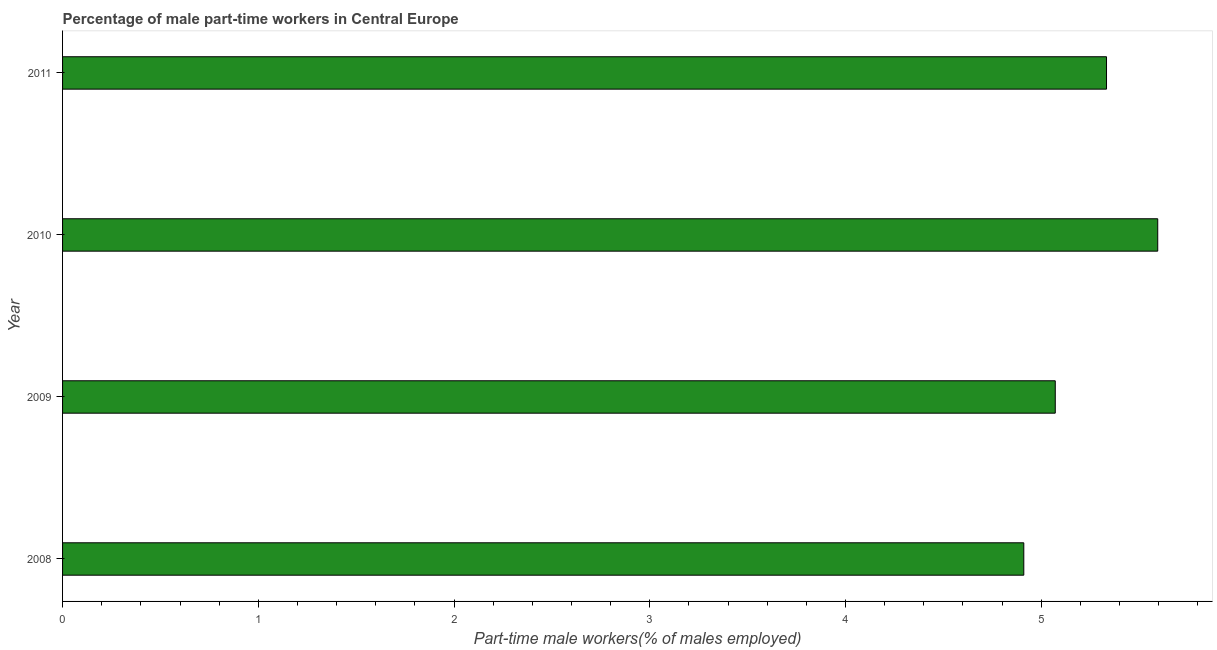Does the graph contain any zero values?
Your answer should be very brief. No. What is the title of the graph?
Offer a very short reply. Percentage of male part-time workers in Central Europe. What is the label or title of the X-axis?
Provide a succinct answer. Part-time male workers(% of males employed). What is the percentage of part-time male workers in 2010?
Provide a succinct answer. 5.6. Across all years, what is the maximum percentage of part-time male workers?
Ensure brevity in your answer.  5.6. Across all years, what is the minimum percentage of part-time male workers?
Provide a short and direct response. 4.91. In which year was the percentage of part-time male workers minimum?
Make the answer very short. 2008. What is the sum of the percentage of part-time male workers?
Your answer should be compact. 20.91. What is the difference between the percentage of part-time male workers in 2009 and 2011?
Provide a short and direct response. -0.26. What is the average percentage of part-time male workers per year?
Offer a very short reply. 5.23. What is the median percentage of part-time male workers?
Make the answer very short. 5.2. In how many years, is the percentage of part-time male workers greater than 3.2 %?
Give a very brief answer. 4. Do a majority of the years between 2011 and 2010 (inclusive) have percentage of part-time male workers greater than 0.2 %?
Your answer should be very brief. No. What is the ratio of the percentage of part-time male workers in 2010 to that in 2011?
Provide a short and direct response. 1.05. Is the percentage of part-time male workers in 2009 less than that in 2010?
Your answer should be compact. Yes. What is the difference between the highest and the second highest percentage of part-time male workers?
Offer a very short reply. 0.26. Is the sum of the percentage of part-time male workers in 2009 and 2011 greater than the maximum percentage of part-time male workers across all years?
Offer a very short reply. Yes. What is the difference between the highest and the lowest percentage of part-time male workers?
Keep it short and to the point. 0.68. How many bars are there?
Provide a short and direct response. 4. Are all the bars in the graph horizontal?
Ensure brevity in your answer.  Yes. How many years are there in the graph?
Provide a short and direct response. 4. What is the difference between two consecutive major ticks on the X-axis?
Keep it short and to the point. 1. Are the values on the major ticks of X-axis written in scientific E-notation?
Ensure brevity in your answer.  No. What is the Part-time male workers(% of males employed) of 2008?
Offer a very short reply. 4.91. What is the Part-time male workers(% of males employed) of 2009?
Make the answer very short. 5.07. What is the Part-time male workers(% of males employed) in 2010?
Offer a terse response. 5.6. What is the Part-time male workers(% of males employed) in 2011?
Make the answer very short. 5.33. What is the difference between the Part-time male workers(% of males employed) in 2008 and 2009?
Your answer should be compact. -0.16. What is the difference between the Part-time male workers(% of males employed) in 2008 and 2010?
Provide a short and direct response. -0.68. What is the difference between the Part-time male workers(% of males employed) in 2008 and 2011?
Your response must be concise. -0.42. What is the difference between the Part-time male workers(% of males employed) in 2009 and 2010?
Keep it short and to the point. -0.52. What is the difference between the Part-time male workers(% of males employed) in 2009 and 2011?
Give a very brief answer. -0.26. What is the difference between the Part-time male workers(% of males employed) in 2010 and 2011?
Offer a very short reply. 0.26. What is the ratio of the Part-time male workers(% of males employed) in 2008 to that in 2010?
Ensure brevity in your answer.  0.88. What is the ratio of the Part-time male workers(% of males employed) in 2008 to that in 2011?
Your answer should be compact. 0.92. What is the ratio of the Part-time male workers(% of males employed) in 2009 to that in 2010?
Your response must be concise. 0.91. What is the ratio of the Part-time male workers(% of males employed) in 2009 to that in 2011?
Make the answer very short. 0.95. What is the ratio of the Part-time male workers(% of males employed) in 2010 to that in 2011?
Your answer should be very brief. 1.05. 